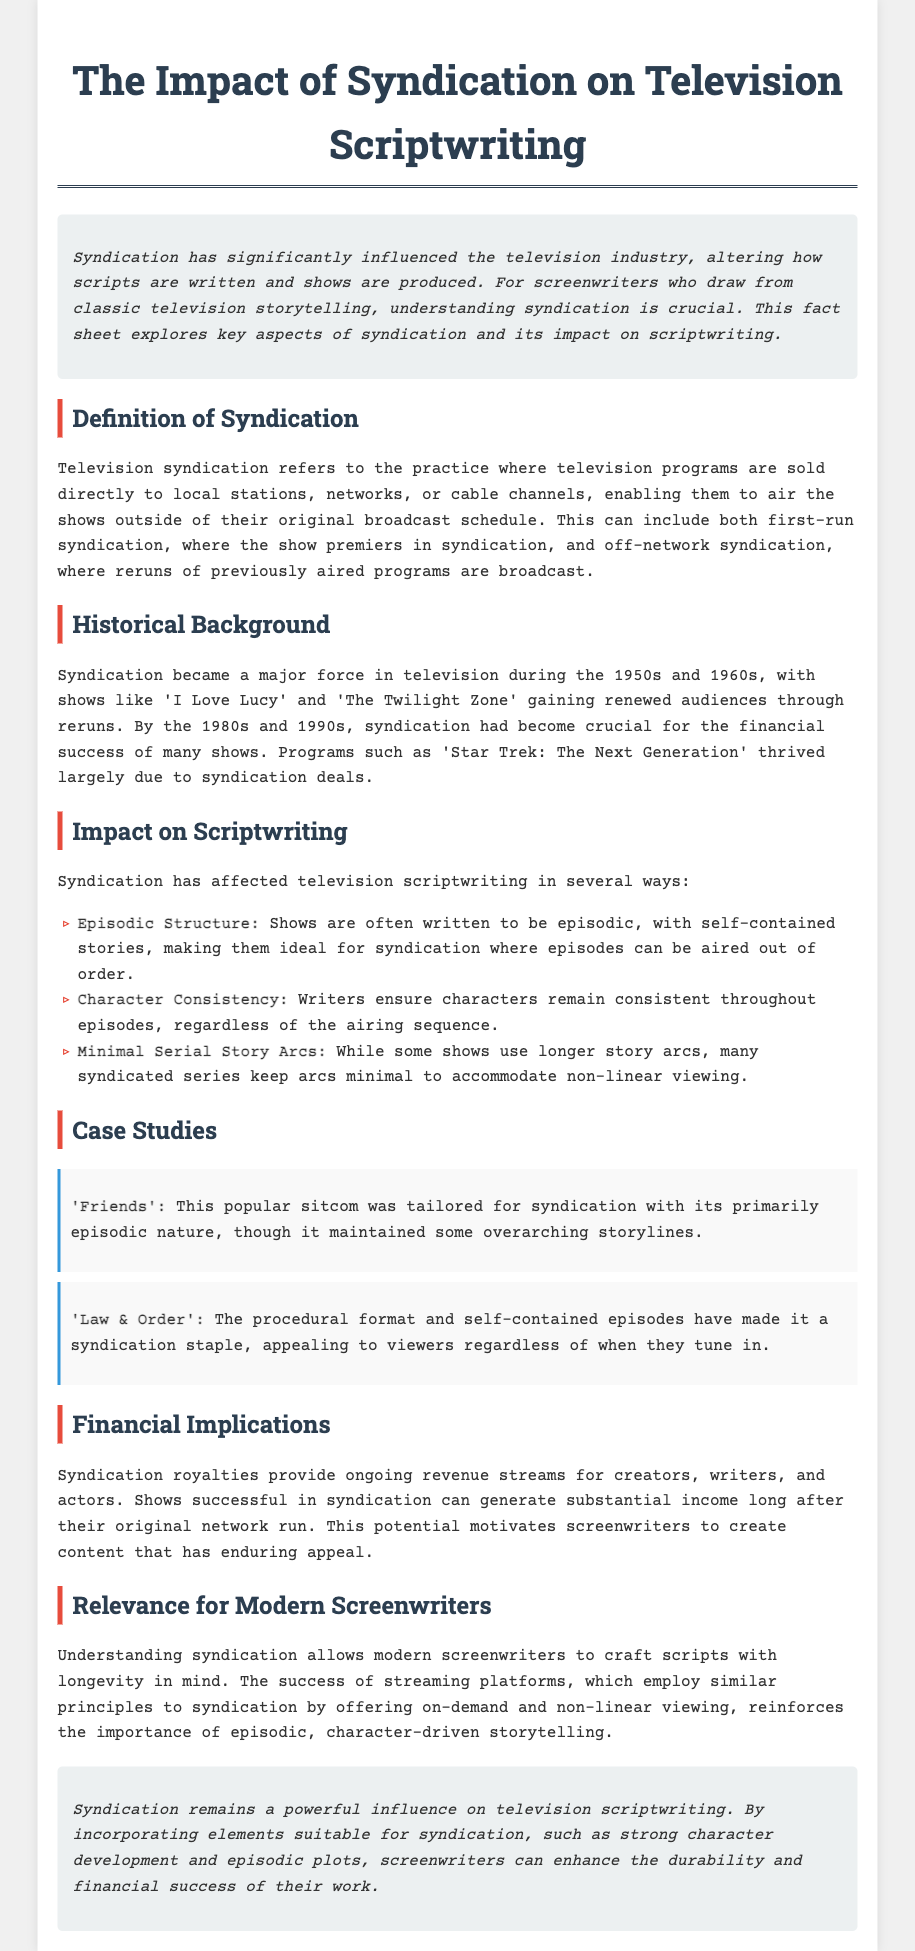what is the title of the document? The title is prominently displayed in the document, stating the focus on syndication and scriptwriting.
Answer: The Impact of Syndication on Television Scriptwriting what decade did syndication become a major force in television? The document mentions the 1950s and 1960s as the time when syndication gained significant importance.
Answer: 1950s and 1960s which sitcom was tailored for syndication? The document provides a specific example of a sitcom that was crafted to succeed in syndication.
Answer: Friends what type of structure is often used in shows for syndication? The document states that shows are typically written to have a certain layout to facilitate syndication viewing.
Answer: Episodic how do syndication royalties affect creators? The document explains the financial benefits that syndication provides for people involved in the television industry.
Answer: Ongoing revenue streams what is one of the character requirements in syndicated storytelling? The document lists a key aspect of character consistency that writers must maintain in syndicated shows.
Answer: Character Consistency what is a common storytelling style in syndication? The document highlights a feature of many shows that suits non-linear viewing.
Answer: Minimal Serial Story Arcs which procedural show is mentioned as a syndication staple? The case studies section lists an example of a procedural format show that thrives in syndication.
Answer: Law & Order 